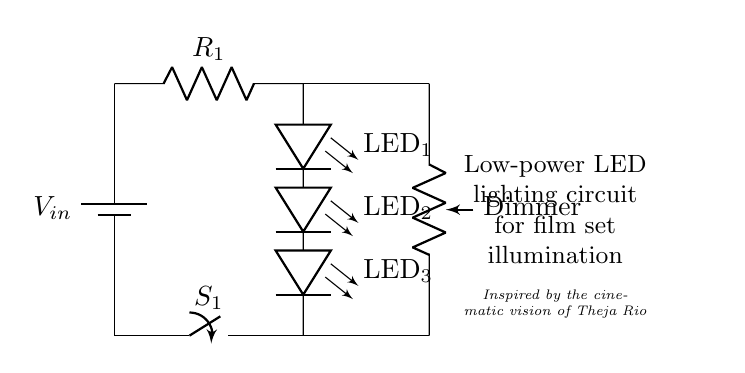What is the type of power supply in this circuit? The circuit uses a battery, indicated by the label 'V_in', providing a direct current (DC) power supply.
Answer: battery How many LEDs are used in the circuit? There are three LEDs in series, as shown in the diagram, labeled LED_1, LED_2, and LED_3.
Answer: three What is the purpose of the resistor labeled R_1? The resistor R_1 is a current limiting resistor, which is essential to prevent excessive current from flowing through the LEDs and potentially damaging them.
Answer: current limiting What is the function of the dimmer in this circuit? The dimmer is a potentiometer that allows for adjusting the brightness of the LEDs by controlling the current flowing through them.
Answer: brightness adjustment What is the state of the switch labeled S_1 in this diagram? The state of switch S_1 can be inferred to be open or closed depending on the configuration in use; however, it directly connects the power supply to the LED circuit.
Answer: open/closed How does the dimmer affect the LEDs in this circuit? The dimmer adjusts the resistance in the circuit, which affects the current passing through the LEDs, thus changing their brightness according to the resistance set on the potentiometer.
Answer: brightness changes 